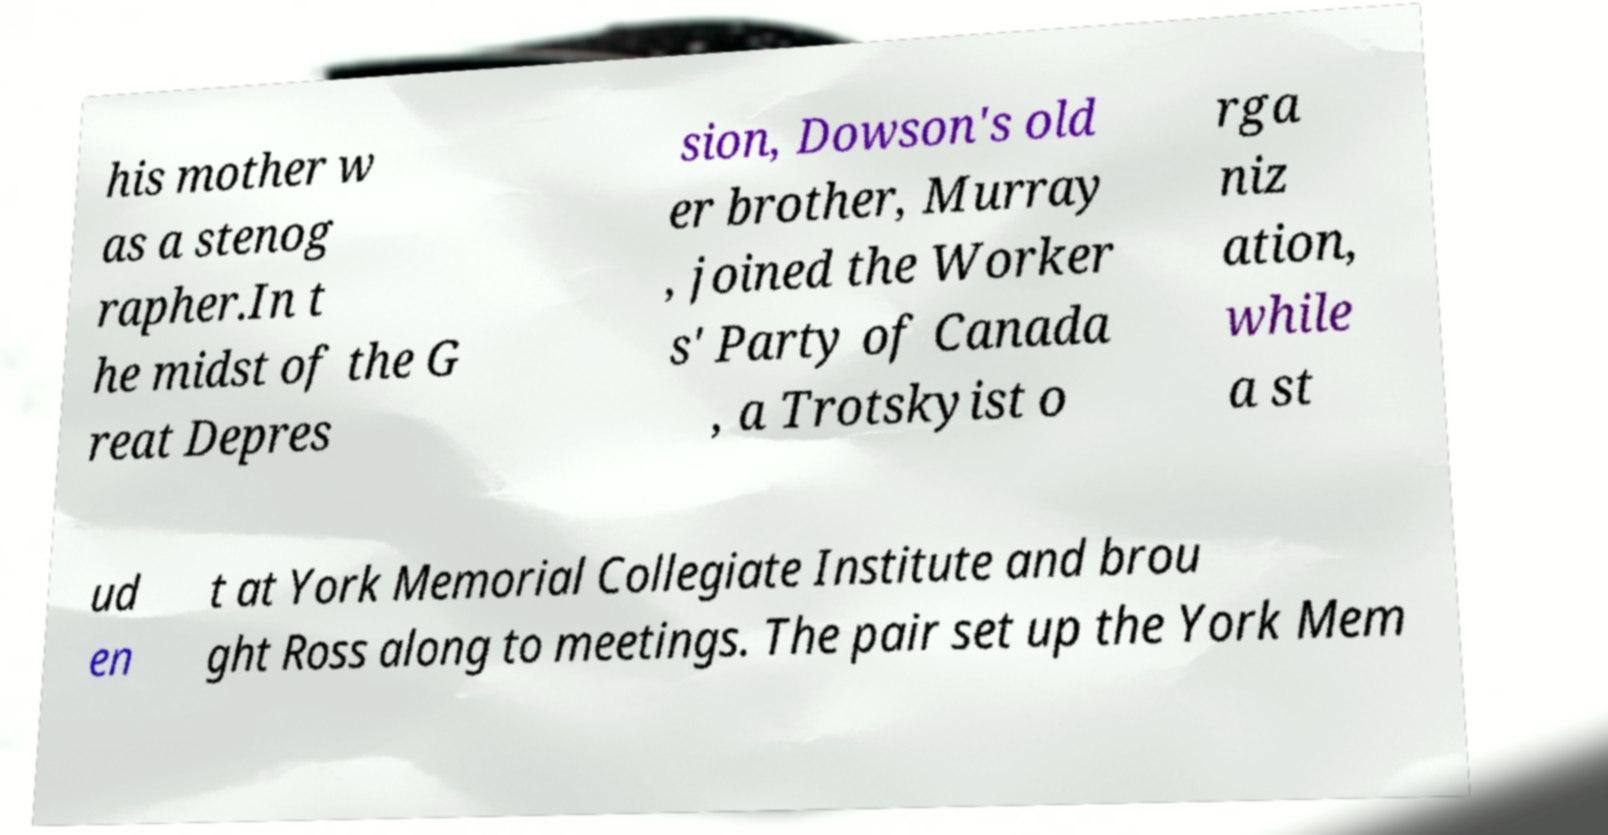For documentation purposes, I need the text within this image transcribed. Could you provide that? his mother w as a stenog rapher.In t he midst of the G reat Depres sion, Dowson's old er brother, Murray , joined the Worker s' Party of Canada , a Trotskyist o rga niz ation, while a st ud en t at York Memorial Collegiate Institute and brou ght Ross along to meetings. The pair set up the York Mem 